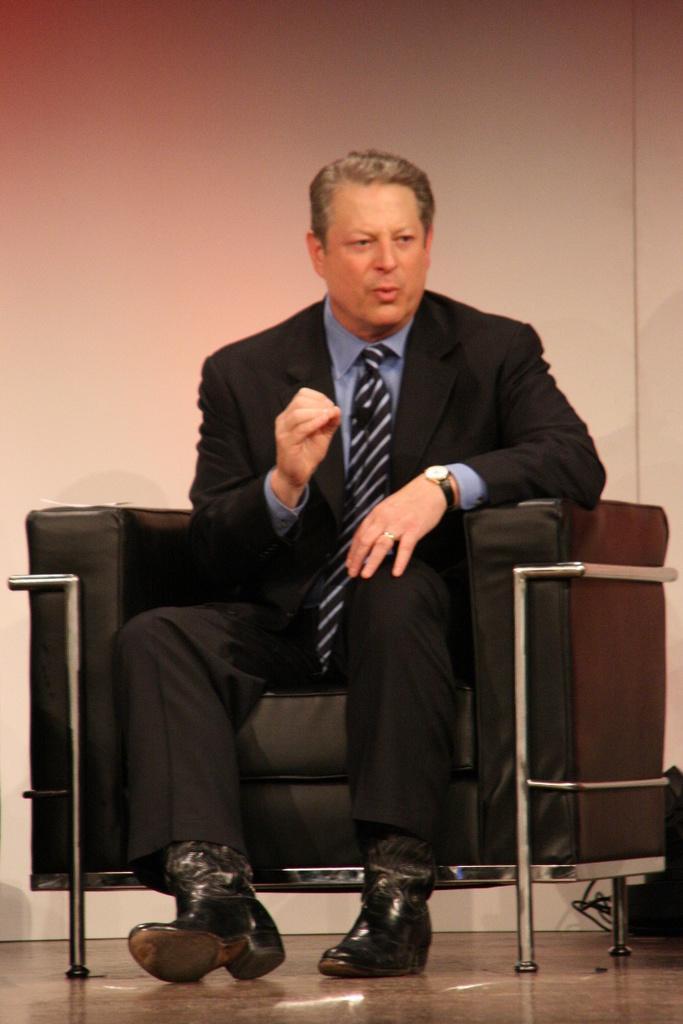In one or two sentences, can you explain what this image depicts? In this image there is a man wearing a suit and sitting in a sofa, in the background there is a wall. 